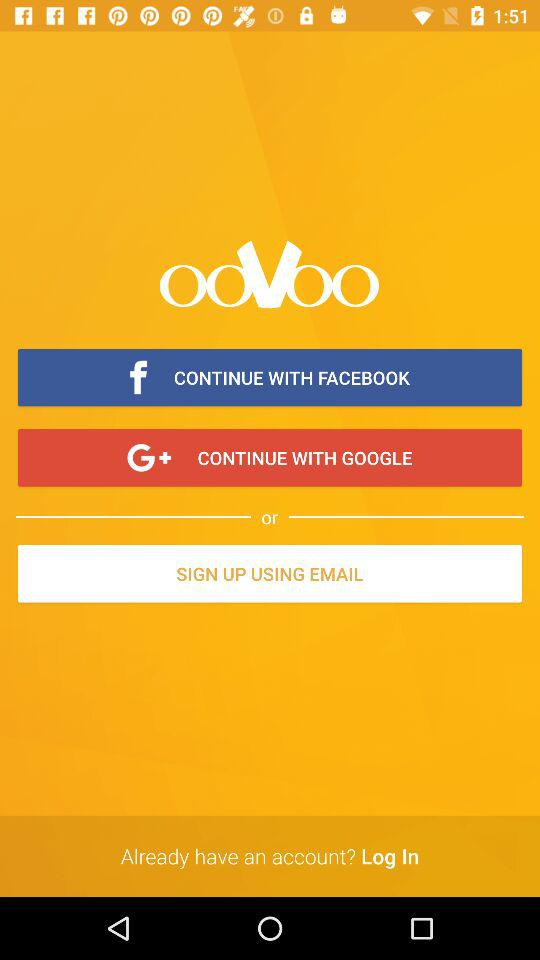What are the given sign up options? The given sign up option is "EMAIL". 